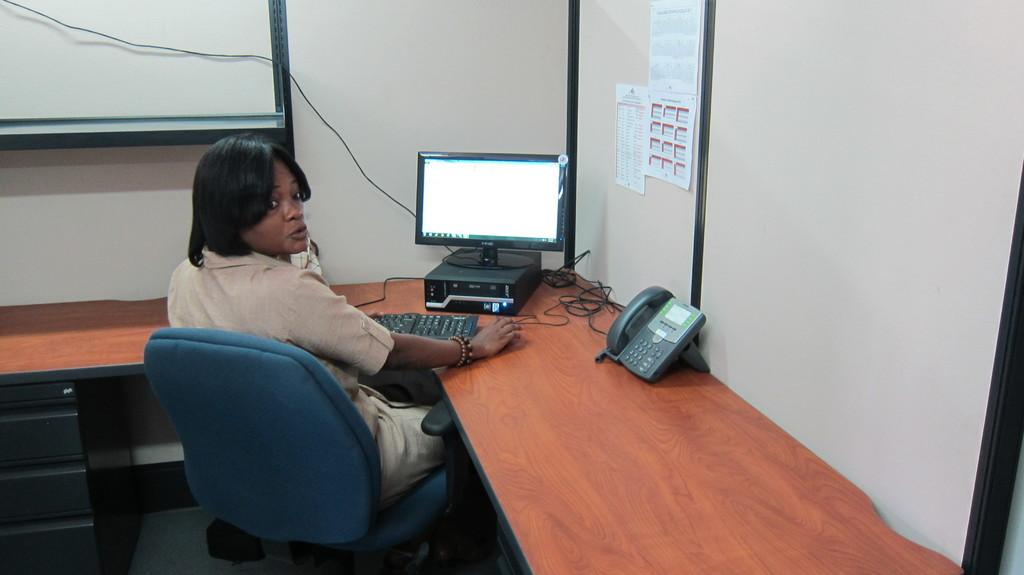What is the woman doing in the image? The woman is sitting on a chair in the image. What is in front of the woman? There is a table in front of the woman. What objects are on the table? A keyboard, a system (likely a computer), and a telephone are on the table. What can be seen on the wall in the image? Papers are on the wall. What is the woman's position relative to the table? The woman is sitting on a chair in front of the table. What type of bear can be seen in the image? There is no bear present in the image; it features a woman sitting on a chair with a table and various objects in front of her. 